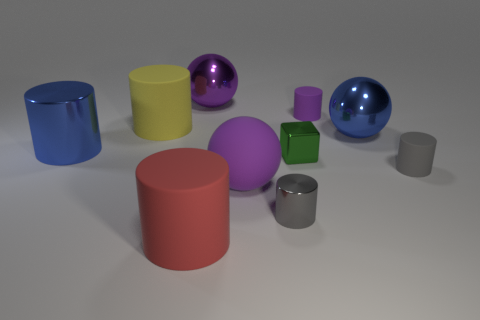Describe the lighting source used in this image based on the shadows and reflections visible. The image appears to be lit by a single, diffused light source coming from above and slightly to the right, as indicated by the soft shadows cast directly to the left of the objects and the subtle highlights on the upper surfaces and edges of the objects. 